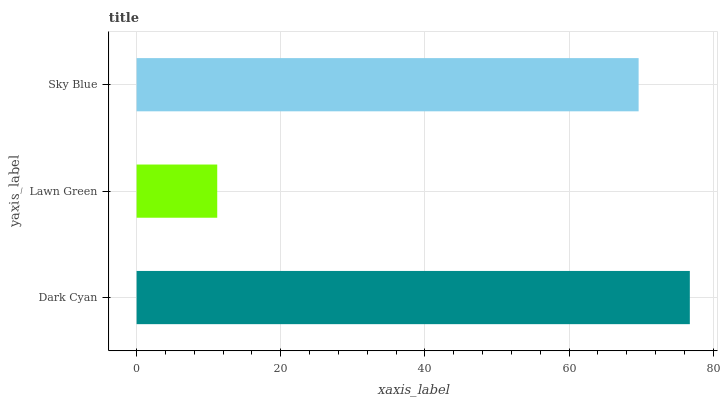Is Lawn Green the minimum?
Answer yes or no. Yes. Is Dark Cyan the maximum?
Answer yes or no. Yes. Is Sky Blue the minimum?
Answer yes or no. No. Is Sky Blue the maximum?
Answer yes or no. No. Is Sky Blue greater than Lawn Green?
Answer yes or no. Yes. Is Lawn Green less than Sky Blue?
Answer yes or no. Yes. Is Lawn Green greater than Sky Blue?
Answer yes or no. No. Is Sky Blue less than Lawn Green?
Answer yes or no. No. Is Sky Blue the high median?
Answer yes or no. Yes. Is Sky Blue the low median?
Answer yes or no. Yes. Is Lawn Green the high median?
Answer yes or no. No. Is Dark Cyan the low median?
Answer yes or no. No. 